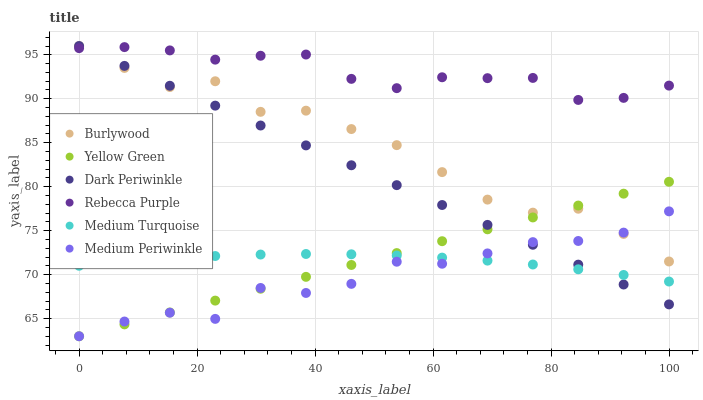Does Medium Periwinkle have the minimum area under the curve?
Answer yes or no. Yes. Does Rebecca Purple have the maximum area under the curve?
Answer yes or no. Yes. Does Burlywood have the minimum area under the curve?
Answer yes or no. No. Does Burlywood have the maximum area under the curve?
Answer yes or no. No. Is Yellow Green the smoothest?
Answer yes or no. Yes. Is Burlywood the roughest?
Answer yes or no. Yes. Is Medium Periwinkle the smoothest?
Answer yes or no. No. Is Medium Periwinkle the roughest?
Answer yes or no. No. Does Yellow Green have the lowest value?
Answer yes or no. Yes. Does Burlywood have the lowest value?
Answer yes or no. No. Does Dark Periwinkle have the highest value?
Answer yes or no. Yes. Does Medium Periwinkle have the highest value?
Answer yes or no. No. Is Medium Periwinkle less than Rebecca Purple?
Answer yes or no. Yes. Is Rebecca Purple greater than Medium Periwinkle?
Answer yes or no. Yes. Does Dark Periwinkle intersect Rebecca Purple?
Answer yes or no. Yes. Is Dark Periwinkle less than Rebecca Purple?
Answer yes or no. No. Is Dark Periwinkle greater than Rebecca Purple?
Answer yes or no. No. Does Medium Periwinkle intersect Rebecca Purple?
Answer yes or no. No. 